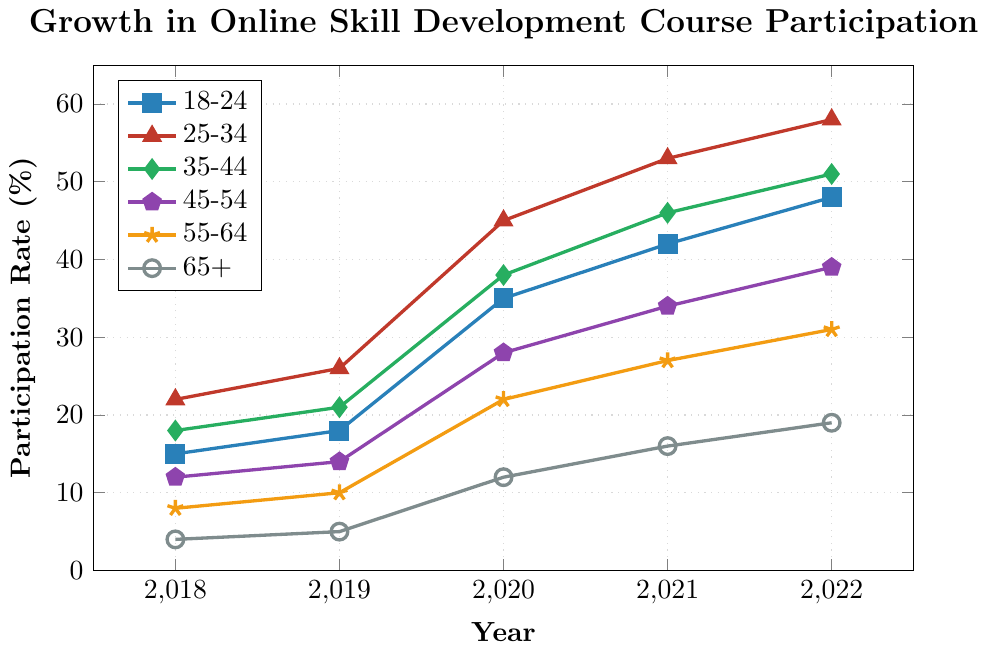What is the participation rate for the 18-24 age group in 2021? Look at the plotted line for the 18-24 age group (identified by color and line type) and find the corresponding y-value for the year 2021 on the x-axis. The rate is 42%.
Answer: 42 Which age group had the highest participation rate in 2020? Identify the data point for each age group in 2020 and compare their y-values. The age group 25-34 had the highest participation rate at 45%.
Answer: 25-34 By how much did the participation rate for the 45-54 age group increase from 2018 to 2022? Subtract the participation rate for the 45-54 age group in 2018 (12) from the rate in 2022 (39). The increase is 39 - 12 = 27%.
Answer: 27 Which age group showed the smallest increase in participation rate from 2018 to 2022? Calculate the difference in participation rates for each age group between 2018 and 2022, then identify the smallest difference. The 65+ age group increased from 4% to 19%, giving an increase of 15%, which is the smallest.
Answer: 65+ What is the combined participation rate for the 18-24 and 25-34 age groups in 2022? Add the participation rates for the 18-24 age group (48%) and the 25-34 age group (58%) in 2022. The combined rate is 48 + 58 = 106%.
Answer: 106 Which two age groups saw the most similar growth trends over the period from 2018 to 2022? Visually compare the slopes and patterns of the lines for each age group. The 35-44 and 45-54 age groups have the most similar growth trends, both showing consistent increases.
Answer: 35-44 and 45-54 What is the average participation rate for the 35-44 age group over the period 2018 to 2022? Add the participation rates for the 35-44 age group from 2018 to 2022 (18, 21, 38, 46, 51) and divide by the number of years, which is 5. The average rate is (18 + 21 + 38 + 46 + 51) / 5 = 34.8%.
Answer: 34.8 Does the 55-64 age group show a steady increase in participation rate over the years? Examine the trend line for the 55-64 age group and check if the y-values consistently increase from 2018 to 2022. The participation rate starts at 8% in 2018 and reaches 31% in 2022, showing a steady increase every year.
Answer: Yes 